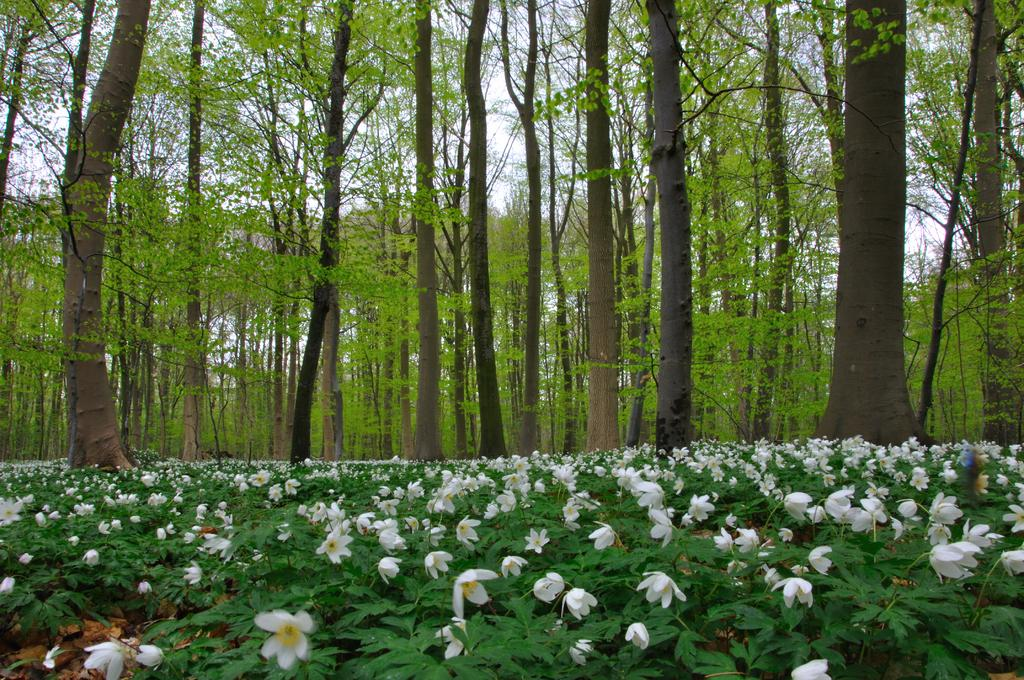What is the main subject in the center of the image? There are plants in the center of the image. What can be found among the plants? There are flowers among the plants. What colors are the flowers? The flowers are white and yellow in color. What is visible in the background of the image? There is sky, clouds, and trees visible in the background of the image. How does the corn in the image help to increase the plant's balance? There is no corn present in the image, so it cannot help to increase the plant's balance. 